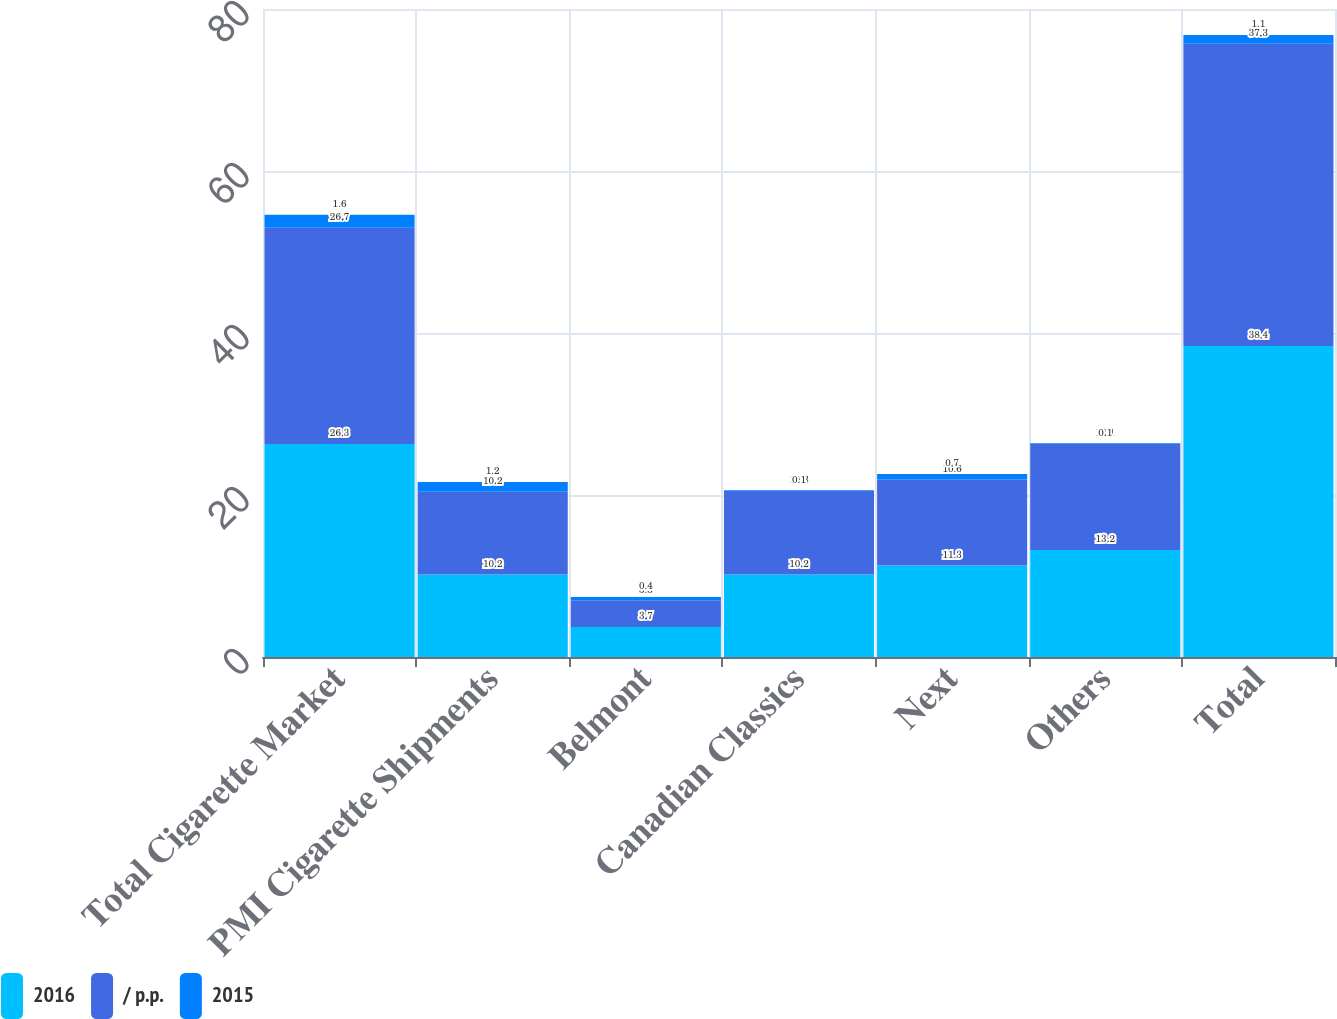<chart> <loc_0><loc_0><loc_500><loc_500><stacked_bar_chart><ecel><fcel>Total Cigarette Market<fcel>PMI Cigarette Shipments<fcel>Belmont<fcel>Canadian Classics<fcel>Next<fcel>Others<fcel>Total<nl><fcel>2016<fcel>26.3<fcel>10.2<fcel>3.7<fcel>10.2<fcel>11.3<fcel>13.2<fcel>38.4<nl><fcel>/ p.p.<fcel>26.7<fcel>10.2<fcel>3.3<fcel>10.3<fcel>10.6<fcel>13.1<fcel>37.3<nl><fcel>2015<fcel>1.6<fcel>1.2<fcel>0.4<fcel>0.1<fcel>0.7<fcel>0.1<fcel>1.1<nl></chart> 